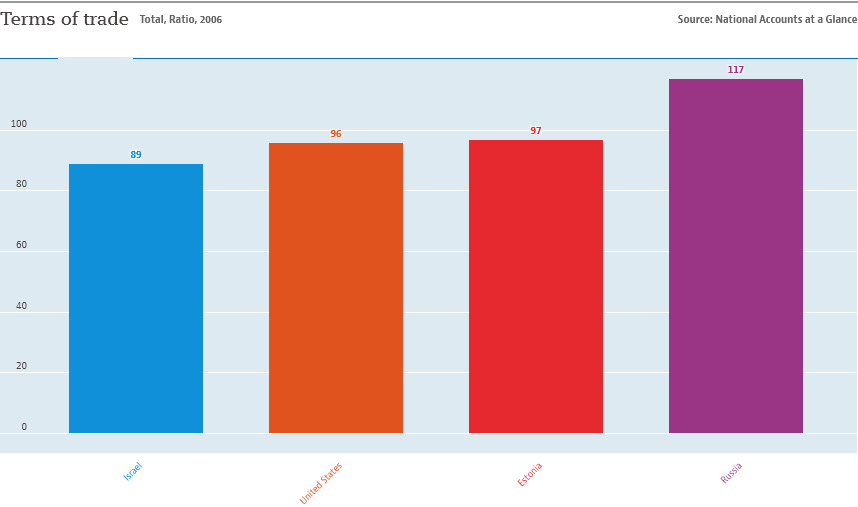List a handful of essential elements in this visual. The country represented by the blue bar is Israel. The total value of the smallest two bars is 185. 